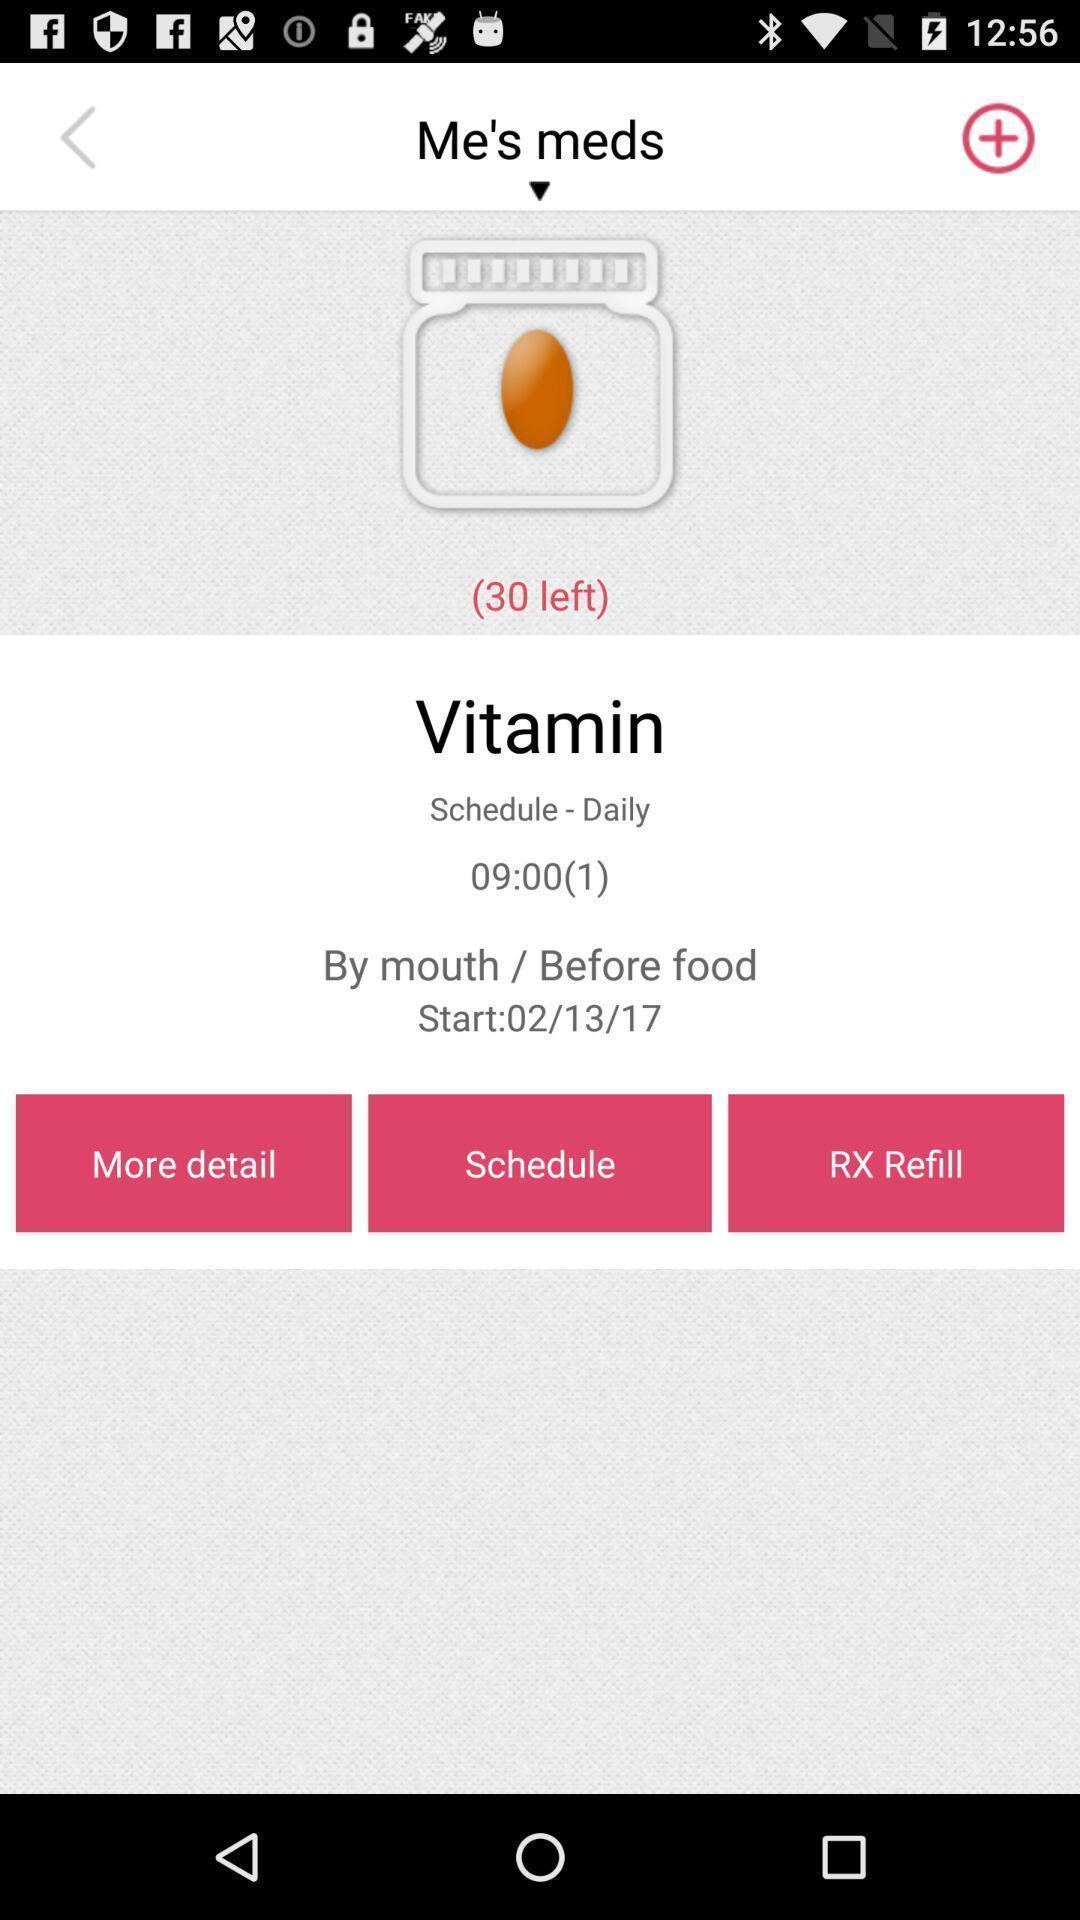Describe this image in words. Page showing the options in food app. 